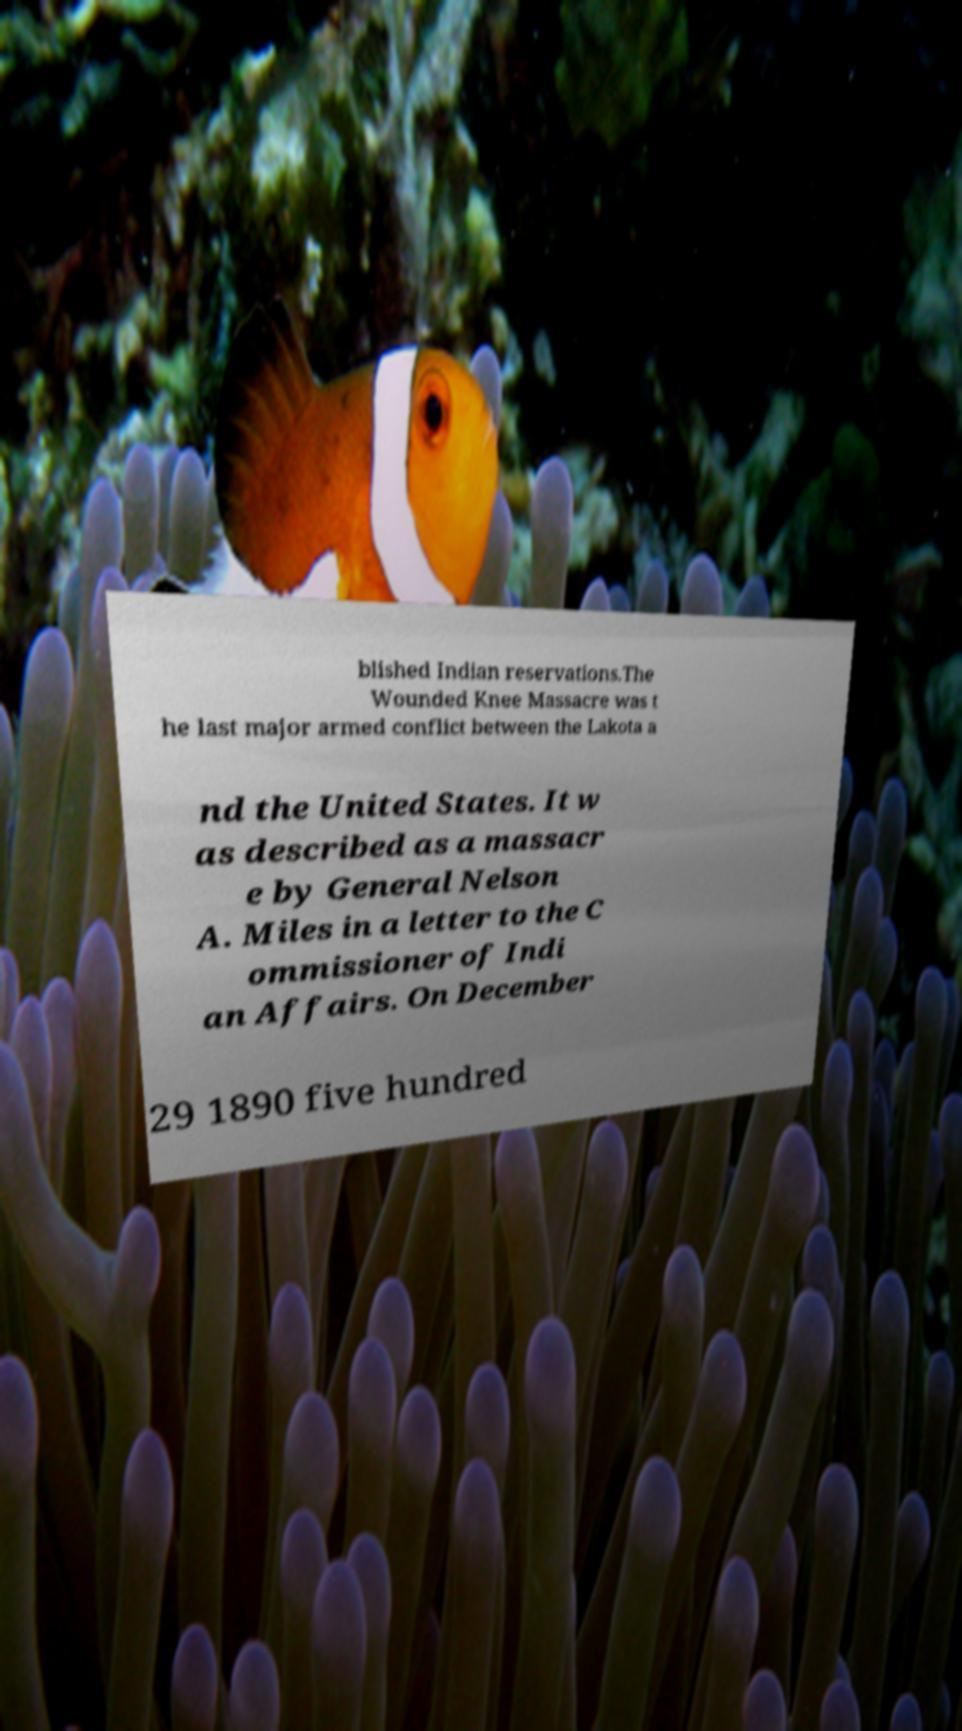Please identify and transcribe the text found in this image. blished Indian reservations.The Wounded Knee Massacre was t he last major armed conflict between the Lakota a nd the United States. It w as described as a massacr e by General Nelson A. Miles in a letter to the C ommissioner of Indi an Affairs. On December 29 1890 five hundred 